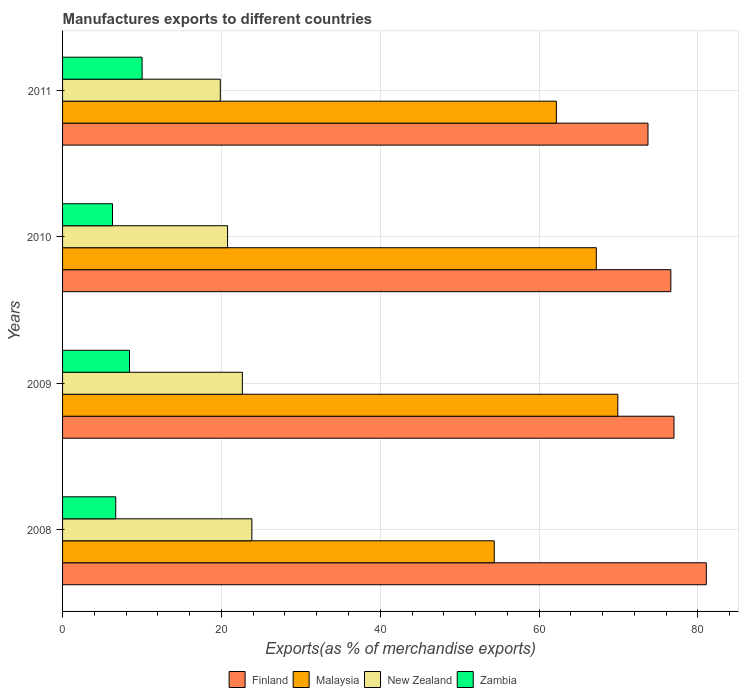Are the number of bars on each tick of the Y-axis equal?
Your answer should be very brief. Yes. What is the percentage of exports to different countries in Zambia in 2009?
Offer a very short reply. 8.43. Across all years, what is the maximum percentage of exports to different countries in Malaysia?
Provide a succinct answer. 69.91. Across all years, what is the minimum percentage of exports to different countries in Finland?
Ensure brevity in your answer.  73.71. In which year was the percentage of exports to different countries in Zambia maximum?
Provide a short and direct response. 2011. In which year was the percentage of exports to different countries in Zambia minimum?
Keep it short and to the point. 2010. What is the total percentage of exports to different countries in Zambia in the graph?
Keep it short and to the point. 31.42. What is the difference between the percentage of exports to different countries in Finland in 2009 and that in 2010?
Offer a very short reply. 0.4. What is the difference between the percentage of exports to different countries in New Zealand in 2010 and the percentage of exports to different countries in Zambia in 2009?
Make the answer very short. 12.35. What is the average percentage of exports to different countries in Malaysia per year?
Provide a short and direct response. 63.41. In the year 2009, what is the difference between the percentage of exports to different countries in Finland and percentage of exports to different countries in New Zealand?
Your response must be concise. 54.35. In how many years, is the percentage of exports to different countries in Finland greater than 8 %?
Keep it short and to the point. 4. What is the ratio of the percentage of exports to different countries in Malaysia in 2008 to that in 2011?
Your answer should be compact. 0.87. Is the percentage of exports to different countries in Finland in 2008 less than that in 2010?
Offer a terse response. No. Is the difference between the percentage of exports to different countries in Finland in 2008 and 2009 greater than the difference between the percentage of exports to different countries in New Zealand in 2008 and 2009?
Your answer should be very brief. Yes. What is the difference between the highest and the second highest percentage of exports to different countries in Finland?
Ensure brevity in your answer.  4.07. What is the difference between the highest and the lowest percentage of exports to different countries in Finland?
Offer a very short reply. 7.34. In how many years, is the percentage of exports to different countries in New Zealand greater than the average percentage of exports to different countries in New Zealand taken over all years?
Offer a very short reply. 2. What does the 2nd bar from the top in 2010 represents?
Provide a succinct answer. New Zealand. What does the 3rd bar from the bottom in 2009 represents?
Offer a very short reply. New Zealand. Is it the case that in every year, the sum of the percentage of exports to different countries in Malaysia and percentage of exports to different countries in Zambia is greater than the percentage of exports to different countries in New Zealand?
Your response must be concise. Yes. How many bars are there?
Your response must be concise. 16. Are the values on the major ticks of X-axis written in scientific E-notation?
Ensure brevity in your answer.  No. What is the title of the graph?
Your answer should be very brief. Manufactures exports to different countries. Does "Haiti" appear as one of the legend labels in the graph?
Offer a very short reply. No. What is the label or title of the X-axis?
Your answer should be compact. Exports(as % of merchandise exports). What is the Exports(as % of merchandise exports) in Finland in 2008?
Provide a short and direct response. 81.05. What is the Exports(as % of merchandise exports) in Malaysia in 2008?
Your answer should be very brief. 54.35. What is the Exports(as % of merchandise exports) of New Zealand in 2008?
Keep it short and to the point. 23.83. What is the Exports(as % of merchandise exports) of Zambia in 2008?
Provide a succinct answer. 6.7. What is the Exports(as % of merchandise exports) in Finland in 2009?
Provide a succinct answer. 76.98. What is the Exports(as % of merchandise exports) in Malaysia in 2009?
Make the answer very short. 69.91. What is the Exports(as % of merchandise exports) of New Zealand in 2009?
Your response must be concise. 22.64. What is the Exports(as % of merchandise exports) of Zambia in 2009?
Keep it short and to the point. 8.43. What is the Exports(as % of merchandise exports) in Finland in 2010?
Provide a succinct answer. 76.59. What is the Exports(as % of merchandise exports) in Malaysia in 2010?
Give a very brief answer. 67.2. What is the Exports(as % of merchandise exports) in New Zealand in 2010?
Offer a very short reply. 20.78. What is the Exports(as % of merchandise exports) of Zambia in 2010?
Provide a succinct answer. 6.29. What is the Exports(as % of merchandise exports) of Finland in 2011?
Your response must be concise. 73.71. What is the Exports(as % of merchandise exports) in Malaysia in 2011?
Provide a succinct answer. 62.18. What is the Exports(as % of merchandise exports) of New Zealand in 2011?
Your response must be concise. 19.86. What is the Exports(as % of merchandise exports) in Zambia in 2011?
Ensure brevity in your answer.  10.01. Across all years, what is the maximum Exports(as % of merchandise exports) in Finland?
Offer a very short reply. 81.05. Across all years, what is the maximum Exports(as % of merchandise exports) of Malaysia?
Make the answer very short. 69.91. Across all years, what is the maximum Exports(as % of merchandise exports) of New Zealand?
Provide a short and direct response. 23.83. Across all years, what is the maximum Exports(as % of merchandise exports) of Zambia?
Your response must be concise. 10.01. Across all years, what is the minimum Exports(as % of merchandise exports) in Finland?
Offer a terse response. 73.71. Across all years, what is the minimum Exports(as % of merchandise exports) of Malaysia?
Your answer should be compact. 54.35. Across all years, what is the minimum Exports(as % of merchandise exports) in New Zealand?
Offer a very short reply. 19.86. Across all years, what is the minimum Exports(as % of merchandise exports) in Zambia?
Keep it short and to the point. 6.29. What is the total Exports(as % of merchandise exports) in Finland in the graph?
Provide a succinct answer. 308.34. What is the total Exports(as % of merchandise exports) of Malaysia in the graph?
Your response must be concise. 253.65. What is the total Exports(as % of merchandise exports) of New Zealand in the graph?
Your response must be concise. 87.11. What is the total Exports(as % of merchandise exports) of Zambia in the graph?
Offer a terse response. 31.42. What is the difference between the Exports(as % of merchandise exports) of Finland in 2008 and that in 2009?
Provide a succinct answer. 4.07. What is the difference between the Exports(as % of merchandise exports) of Malaysia in 2008 and that in 2009?
Your answer should be very brief. -15.56. What is the difference between the Exports(as % of merchandise exports) in New Zealand in 2008 and that in 2009?
Ensure brevity in your answer.  1.2. What is the difference between the Exports(as % of merchandise exports) in Zambia in 2008 and that in 2009?
Offer a very short reply. -1.73. What is the difference between the Exports(as % of merchandise exports) in Finland in 2008 and that in 2010?
Your answer should be compact. 4.47. What is the difference between the Exports(as % of merchandise exports) in Malaysia in 2008 and that in 2010?
Make the answer very short. -12.85. What is the difference between the Exports(as % of merchandise exports) of New Zealand in 2008 and that in 2010?
Your answer should be very brief. 3.06. What is the difference between the Exports(as % of merchandise exports) in Zambia in 2008 and that in 2010?
Provide a succinct answer. 0.41. What is the difference between the Exports(as % of merchandise exports) of Finland in 2008 and that in 2011?
Offer a terse response. 7.34. What is the difference between the Exports(as % of merchandise exports) of Malaysia in 2008 and that in 2011?
Provide a succinct answer. -7.82. What is the difference between the Exports(as % of merchandise exports) in New Zealand in 2008 and that in 2011?
Make the answer very short. 3.97. What is the difference between the Exports(as % of merchandise exports) of Zambia in 2008 and that in 2011?
Make the answer very short. -3.31. What is the difference between the Exports(as % of merchandise exports) in Finland in 2009 and that in 2010?
Your answer should be compact. 0.4. What is the difference between the Exports(as % of merchandise exports) in Malaysia in 2009 and that in 2010?
Offer a terse response. 2.71. What is the difference between the Exports(as % of merchandise exports) in New Zealand in 2009 and that in 2010?
Ensure brevity in your answer.  1.86. What is the difference between the Exports(as % of merchandise exports) in Zambia in 2009 and that in 2010?
Your response must be concise. 2.14. What is the difference between the Exports(as % of merchandise exports) in Finland in 2009 and that in 2011?
Give a very brief answer. 3.27. What is the difference between the Exports(as % of merchandise exports) in Malaysia in 2009 and that in 2011?
Provide a succinct answer. 7.74. What is the difference between the Exports(as % of merchandise exports) in New Zealand in 2009 and that in 2011?
Provide a short and direct response. 2.78. What is the difference between the Exports(as % of merchandise exports) of Zambia in 2009 and that in 2011?
Offer a very short reply. -1.58. What is the difference between the Exports(as % of merchandise exports) of Finland in 2010 and that in 2011?
Provide a short and direct response. 2.88. What is the difference between the Exports(as % of merchandise exports) in Malaysia in 2010 and that in 2011?
Offer a very short reply. 5.03. What is the difference between the Exports(as % of merchandise exports) of New Zealand in 2010 and that in 2011?
Provide a succinct answer. 0.92. What is the difference between the Exports(as % of merchandise exports) in Zambia in 2010 and that in 2011?
Offer a very short reply. -3.72. What is the difference between the Exports(as % of merchandise exports) in Finland in 2008 and the Exports(as % of merchandise exports) in Malaysia in 2009?
Your answer should be very brief. 11.14. What is the difference between the Exports(as % of merchandise exports) in Finland in 2008 and the Exports(as % of merchandise exports) in New Zealand in 2009?
Make the answer very short. 58.42. What is the difference between the Exports(as % of merchandise exports) in Finland in 2008 and the Exports(as % of merchandise exports) in Zambia in 2009?
Offer a very short reply. 72.63. What is the difference between the Exports(as % of merchandise exports) in Malaysia in 2008 and the Exports(as % of merchandise exports) in New Zealand in 2009?
Give a very brief answer. 31.71. What is the difference between the Exports(as % of merchandise exports) of Malaysia in 2008 and the Exports(as % of merchandise exports) of Zambia in 2009?
Give a very brief answer. 45.93. What is the difference between the Exports(as % of merchandise exports) of New Zealand in 2008 and the Exports(as % of merchandise exports) of Zambia in 2009?
Make the answer very short. 15.41. What is the difference between the Exports(as % of merchandise exports) of Finland in 2008 and the Exports(as % of merchandise exports) of Malaysia in 2010?
Provide a succinct answer. 13.85. What is the difference between the Exports(as % of merchandise exports) in Finland in 2008 and the Exports(as % of merchandise exports) in New Zealand in 2010?
Provide a short and direct response. 60.28. What is the difference between the Exports(as % of merchandise exports) in Finland in 2008 and the Exports(as % of merchandise exports) in Zambia in 2010?
Your response must be concise. 74.77. What is the difference between the Exports(as % of merchandise exports) of Malaysia in 2008 and the Exports(as % of merchandise exports) of New Zealand in 2010?
Offer a very short reply. 33.58. What is the difference between the Exports(as % of merchandise exports) of Malaysia in 2008 and the Exports(as % of merchandise exports) of Zambia in 2010?
Your response must be concise. 48.07. What is the difference between the Exports(as % of merchandise exports) of New Zealand in 2008 and the Exports(as % of merchandise exports) of Zambia in 2010?
Provide a short and direct response. 17.55. What is the difference between the Exports(as % of merchandise exports) of Finland in 2008 and the Exports(as % of merchandise exports) of Malaysia in 2011?
Offer a terse response. 18.88. What is the difference between the Exports(as % of merchandise exports) of Finland in 2008 and the Exports(as % of merchandise exports) of New Zealand in 2011?
Provide a succinct answer. 61.19. What is the difference between the Exports(as % of merchandise exports) in Finland in 2008 and the Exports(as % of merchandise exports) in Zambia in 2011?
Your answer should be very brief. 71.04. What is the difference between the Exports(as % of merchandise exports) in Malaysia in 2008 and the Exports(as % of merchandise exports) in New Zealand in 2011?
Give a very brief answer. 34.49. What is the difference between the Exports(as % of merchandise exports) of Malaysia in 2008 and the Exports(as % of merchandise exports) of Zambia in 2011?
Your answer should be compact. 44.34. What is the difference between the Exports(as % of merchandise exports) of New Zealand in 2008 and the Exports(as % of merchandise exports) of Zambia in 2011?
Your answer should be compact. 13.82. What is the difference between the Exports(as % of merchandise exports) in Finland in 2009 and the Exports(as % of merchandise exports) in Malaysia in 2010?
Provide a short and direct response. 9.78. What is the difference between the Exports(as % of merchandise exports) of Finland in 2009 and the Exports(as % of merchandise exports) of New Zealand in 2010?
Offer a terse response. 56.21. What is the difference between the Exports(as % of merchandise exports) of Finland in 2009 and the Exports(as % of merchandise exports) of Zambia in 2010?
Provide a short and direct response. 70.7. What is the difference between the Exports(as % of merchandise exports) of Malaysia in 2009 and the Exports(as % of merchandise exports) of New Zealand in 2010?
Offer a terse response. 49.14. What is the difference between the Exports(as % of merchandise exports) in Malaysia in 2009 and the Exports(as % of merchandise exports) in Zambia in 2010?
Your answer should be very brief. 63.62. What is the difference between the Exports(as % of merchandise exports) of New Zealand in 2009 and the Exports(as % of merchandise exports) of Zambia in 2010?
Make the answer very short. 16.35. What is the difference between the Exports(as % of merchandise exports) of Finland in 2009 and the Exports(as % of merchandise exports) of Malaysia in 2011?
Your answer should be compact. 14.81. What is the difference between the Exports(as % of merchandise exports) in Finland in 2009 and the Exports(as % of merchandise exports) in New Zealand in 2011?
Provide a succinct answer. 57.12. What is the difference between the Exports(as % of merchandise exports) in Finland in 2009 and the Exports(as % of merchandise exports) in Zambia in 2011?
Your response must be concise. 66.97. What is the difference between the Exports(as % of merchandise exports) in Malaysia in 2009 and the Exports(as % of merchandise exports) in New Zealand in 2011?
Provide a succinct answer. 50.05. What is the difference between the Exports(as % of merchandise exports) in Malaysia in 2009 and the Exports(as % of merchandise exports) in Zambia in 2011?
Your response must be concise. 59.9. What is the difference between the Exports(as % of merchandise exports) of New Zealand in 2009 and the Exports(as % of merchandise exports) of Zambia in 2011?
Your response must be concise. 12.63. What is the difference between the Exports(as % of merchandise exports) in Finland in 2010 and the Exports(as % of merchandise exports) in Malaysia in 2011?
Provide a succinct answer. 14.41. What is the difference between the Exports(as % of merchandise exports) of Finland in 2010 and the Exports(as % of merchandise exports) of New Zealand in 2011?
Your answer should be very brief. 56.73. What is the difference between the Exports(as % of merchandise exports) in Finland in 2010 and the Exports(as % of merchandise exports) in Zambia in 2011?
Keep it short and to the point. 66.58. What is the difference between the Exports(as % of merchandise exports) in Malaysia in 2010 and the Exports(as % of merchandise exports) in New Zealand in 2011?
Provide a short and direct response. 47.34. What is the difference between the Exports(as % of merchandise exports) of Malaysia in 2010 and the Exports(as % of merchandise exports) of Zambia in 2011?
Offer a very short reply. 57.19. What is the difference between the Exports(as % of merchandise exports) of New Zealand in 2010 and the Exports(as % of merchandise exports) of Zambia in 2011?
Provide a succinct answer. 10.77. What is the average Exports(as % of merchandise exports) of Finland per year?
Make the answer very short. 77.08. What is the average Exports(as % of merchandise exports) in Malaysia per year?
Your answer should be compact. 63.41. What is the average Exports(as % of merchandise exports) in New Zealand per year?
Give a very brief answer. 21.78. What is the average Exports(as % of merchandise exports) in Zambia per year?
Your answer should be very brief. 7.86. In the year 2008, what is the difference between the Exports(as % of merchandise exports) in Finland and Exports(as % of merchandise exports) in Malaysia?
Provide a short and direct response. 26.7. In the year 2008, what is the difference between the Exports(as % of merchandise exports) of Finland and Exports(as % of merchandise exports) of New Zealand?
Provide a succinct answer. 57.22. In the year 2008, what is the difference between the Exports(as % of merchandise exports) of Finland and Exports(as % of merchandise exports) of Zambia?
Your answer should be very brief. 74.36. In the year 2008, what is the difference between the Exports(as % of merchandise exports) in Malaysia and Exports(as % of merchandise exports) in New Zealand?
Give a very brief answer. 30.52. In the year 2008, what is the difference between the Exports(as % of merchandise exports) in Malaysia and Exports(as % of merchandise exports) in Zambia?
Keep it short and to the point. 47.66. In the year 2008, what is the difference between the Exports(as % of merchandise exports) in New Zealand and Exports(as % of merchandise exports) in Zambia?
Your answer should be very brief. 17.14. In the year 2009, what is the difference between the Exports(as % of merchandise exports) of Finland and Exports(as % of merchandise exports) of Malaysia?
Offer a terse response. 7.07. In the year 2009, what is the difference between the Exports(as % of merchandise exports) in Finland and Exports(as % of merchandise exports) in New Zealand?
Your response must be concise. 54.35. In the year 2009, what is the difference between the Exports(as % of merchandise exports) in Finland and Exports(as % of merchandise exports) in Zambia?
Provide a succinct answer. 68.56. In the year 2009, what is the difference between the Exports(as % of merchandise exports) of Malaysia and Exports(as % of merchandise exports) of New Zealand?
Your response must be concise. 47.27. In the year 2009, what is the difference between the Exports(as % of merchandise exports) in Malaysia and Exports(as % of merchandise exports) in Zambia?
Your response must be concise. 61.48. In the year 2009, what is the difference between the Exports(as % of merchandise exports) of New Zealand and Exports(as % of merchandise exports) of Zambia?
Offer a terse response. 14.21. In the year 2010, what is the difference between the Exports(as % of merchandise exports) in Finland and Exports(as % of merchandise exports) in Malaysia?
Make the answer very short. 9.38. In the year 2010, what is the difference between the Exports(as % of merchandise exports) of Finland and Exports(as % of merchandise exports) of New Zealand?
Give a very brief answer. 55.81. In the year 2010, what is the difference between the Exports(as % of merchandise exports) in Finland and Exports(as % of merchandise exports) in Zambia?
Offer a very short reply. 70.3. In the year 2010, what is the difference between the Exports(as % of merchandise exports) of Malaysia and Exports(as % of merchandise exports) of New Zealand?
Your response must be concise. 46.43. In the year 2010, what is the difference between the Exports(as % of merchandise exports) in Malaysia and Exports(as % of merchandise exports) in Zambia?
Provide a succinct answer. 60.92. In the year 2010, what is the difference between the Exports(as % of merchandise exports) in New Zealand and Exports(as % of merchandise exports) in Zambia?
Give a very brief answer. 14.49. In the year 2011, what is the difference between the Exports(as % of merchandise exports) of Finland and Exports(as % of merchandise exports) of Malaysia?
Offer a very short reply. 11.53. In the year 2011, what is the difference between the Exports(as % of merchandise exports) in Finland and Exports(as % of merchandise exports) in New Zealand?
Keep it short and to the point. 53.85. In the year 2011, what is the difference between the Exports(as % of merchandise exports) of Finland and Exports(as % of merchandise exports) of Zambia?
Provide a short and direct response. 63.7. In the year 2011, what is the difference between the Exports(as % of merchandise exports) of Malaysia and Exports(as % of merchandise exports) of New Zealand?
Ensure brevity in your answer.  42.32. In the year 2011, what is the difference between the Exports(as % of merchandise exports) in Malaysia and Exports(as % of merchandise exports) in Zambia?
Offer a very short reply. 52.17. In the year 2011, what is the difference between the Exports(as % of merchandise exports) of New Zealand and Exports(as % of merchandise exports) of Zambia?
Offer a terse response. 9.85. What is the ratio of the Exports(as % of merchandise exports) in Finland in 2008 to that in 2009?
Your answer should be compact. 1.05. What is the ratio of the Exports(as % of merchandise exports) of Malaysia in 2008 to that in 2009?
Make the answer very short. 0.78. What is the ratio of the Exports(as % of merchandise exports) in New Zealand in 2008 to that in 2009?
Ensure brevity in your answer.  1.05. What is the ratio of the Exports(as % of merchandise exports) of Zambia in 2008 to that in 2009?
Provide a succinct answer. 0.79. What is the ratio of the Exports(as % of merchandise exports) of Finland in 2008 to that in 2010?
Your answer should be very brief. 1.06. What is the ratio of the Exports(as % of merchandise exports) in Malaysia in 2008 to that in 2010?
Your answer should be compact. 0.81. What is the ratio of the Exports(as % of merchandise exports) of New Zealand in 2008 to that in 2010?
Keep it short and to the point. 1.15. What is the ratio of the Exports(as % of merchandise exports) in Zambia in 2008 to that in 2010?
Keep it short and to the point. 1.06. What is the ratio of the Exports(as % of merchandise exports) in Finland in 2008 to that in 2011?
Give a very brief answer. 1.1. What is the ratio of the Exports(as % of merchandise exports) of Malaysia in 2008 to that in 2011?
Offer a terse response. 0.87. What is the ratio of the Exports(as % of merchandise exports) in New Zealand in 2008 to that in 2011?
Give a very brief answer. 1.2. What is the ratio of the Exports(as % of merchandise exports) in Zambia in 2008 to that in 2011?
Your answer should be compact. 0.67. What is the ratio of the Exports(as % of merchandise exports) of Finland in 2009 to that in 2010?
Give a very brief answer. 1.01. What is the ratio of the Exports(as % of merchandise exports) in Malaysia in 2009 to that in 2010?
Keep it short and to the point. 1.04. What is the ratio of the Exports(as % of merchandise exports) in New Zealand in 2009 to that in 2010?
Keep it short and to the point. 1.09. What is the ratio of the Exports(as % of merchandise exports) of Zambia in 2009 to that in 2010?
Your response must be concise. 1.34. What is the ratio of the Exports(as % of merchandise exports) in Finland in 2009 to that in 2011?
Keep it short and to the point. 1.04. What is the ratio of the Exports(as % of merchandise exports) in Malaysia in 2009 to that in 2011?
Provide a succinct answer. 1.12. What is the ratio of the Exports(as % of merchandise exports) of New Zealand in 2009 to that in 2011?
Give a very brief answer. 1.14. What is the ratio of the Exports(as % of merchandise exports) of Zambia in 2009 to that in 2011?
Your answer should be very brief. 0.84. What is the ratio of the Exports(as % of merchandise exports) of Finland in 2010 to that in 2011?
Make the answer very short. 1.04. What is the ratio of the Exports(as % of merchandise exports) of Malaysia in 2010 to that in 2011?
Ensure brevity in your answer.  1.08. What is the ratio of the Exports(as % of merchandise exports) in New Zealand in 2010 to that in 2011?
Give a very brief answer. 1.05. What is the ratio of the Exports(as % of merchandise exports) in Zambia in 2010 to that in 2011?
Your answer should be very brief. 0.63. What is the difference between the highest and the second highest Exports(as % of merchandise exports) of Finland?
Keep it short and to the point. 4.07. What is the difference between the highest and the second highest Exports(as % of merchandise exports) of Malaysia?
Ensure brevity in your answer.  2.71. What is the difference between the highest and the second highest Exports(as % of merchandise exports) of New Zealand?
Keep it short and to the point. 1.2. What is the difference between the highest and the second highest Exports(as % of merchandise exports) of Zambia?
Provide a succinct answer. 1.58. What is the difference between the highest and the lowest Exports(as % of merchandise exports) of Finland?
Provide a short and direct response. 7.34. What is the difference between the highest and the lowest Exports(as % of merchandise exports) of Malaysia?
Provide a short and direct response. 15.56. What is the difference between the highest and the lowest Exports(as % of merchandise exports) of New Zealand?
Provide a short and direct response. 3.97. What is the difference between the highest and the lowest Exports(as % of merchandise exports) of Zambia?
Your response must be concise. 3.72. 